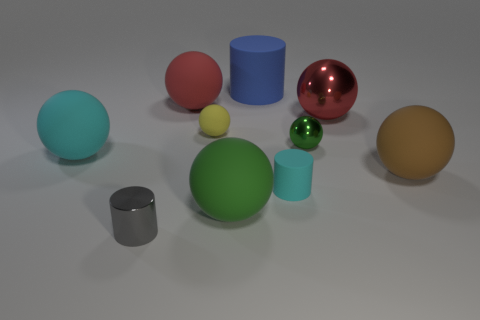What can you tell me about the different materials in the scene? The scene includes objects with various material properties. There's a shiny red metallic sphere, and others that seem to have matte surfaces indicating non-metallic materials. The variety suggests different textures, from smooth and reflective to more diffuse. Do the objects have any shadows? Yes, each object casts a soft shadow on the ground, indicating a light source above the scene. 